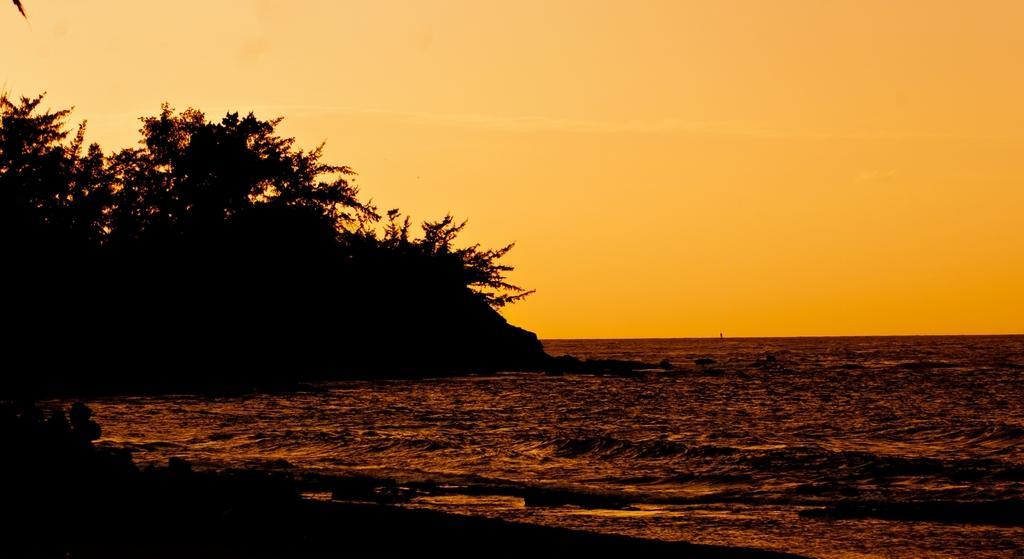Could you give a brief overview of what you see in this image? On the left we can see many trees on the mountain. On the right we can see the ocean. At the top we can see sky and clouds. 